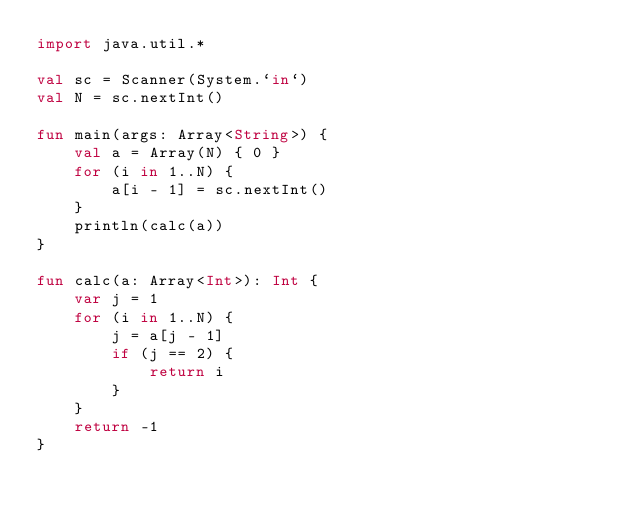<code> <loc_0><loc_0><loc_500><loc_500><_Kotlin_>import java.util.*

val sc = Scanner(System.`in`)
val N = sc.nextInt()

fun main(args: Array<String>) {
    val a = Array(N) { 0 }
    for (i in 1..N) {
        a[i - 1] = sc.nextInt()
    }
    println(calc(a))
}

fun calc(a: Array<Int>): Int {
    var j = 1
    for (i in 1..N) {
        j = a[j - 1]
        if (j == 2) {
            return i
        }
    }
    return -1
}
</code> 